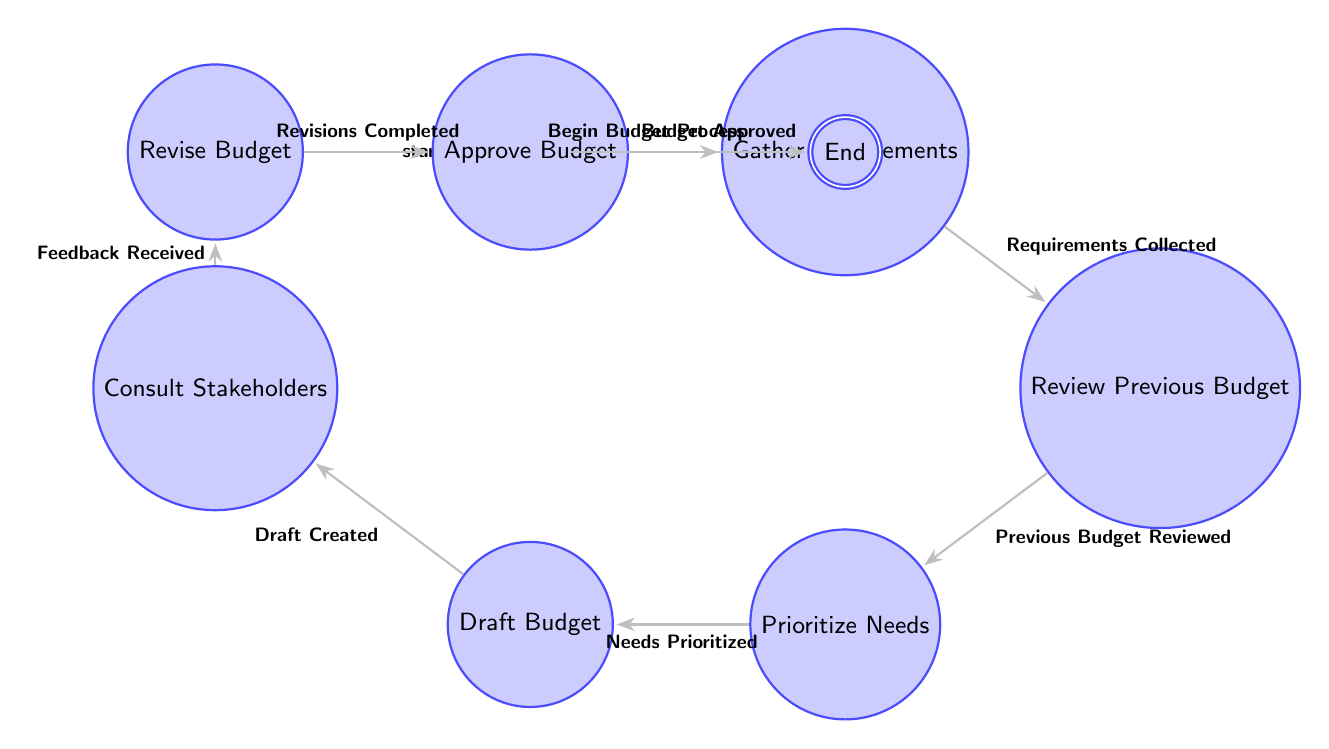What is the first state in the budget allocation process? The diagram starts with the "Start" node, indicating it is the initial state of the budget allocation process.
Answer: Start How many nodes are there in total? Counting all the states listed in the diagram, there are a total of nine nodes, which represent different stages in the budget allocation process.
Answer: Nine What is the final state reached after budget approval? The last state after the budget is approved is the "End" state, signifying the completion of the process.
Answer: End What transition follows after drafting the budget? After the "Draft Budget" state, the next transition moves to "Consult Stakeholders" upon the trigger "Draft Created", indicating the next step involves stakeholder consultation.
Answer: Consult Stakeholders Which state comes immediately after gathering requirements? After the "Gather Requirements" state, the transition occurs to the "Review Previous Budget" state once the requirements are collected.
Answer: Review Previous Budget If the budget is not approved, which state must be returned to for revisions? The flow indicates that if revisions are needed, one must return to the "Revise Budget" state after receiving feedback during the consultation phase.
Answer: Revise Budget What is the trigger that leads from the "Consult Stakeholders" to the "Revise Budget"? The trigger for this transition is "Feedback Received," which means the feedback from stakeholders prompts necessary revisions to the draft budget.
Answer: Feedback Received What is a necessary condition to move from "Prioritize Needs" to "Draft Budget"? The transition from "Prioritize Needs" to "Draft Budget" occurs only when the "Needs Prioritized" trigger is satisfied, signifying all needs have been prioritized.
Answer: Needs Prioritized What connects the "Approve Budget" state to the final "End" state? The connection between "Approve Budget" and "End" is made via the trigger "Budget Approved," indicating the successful approval of the budget before finalization.
Answer: Budget Approved 